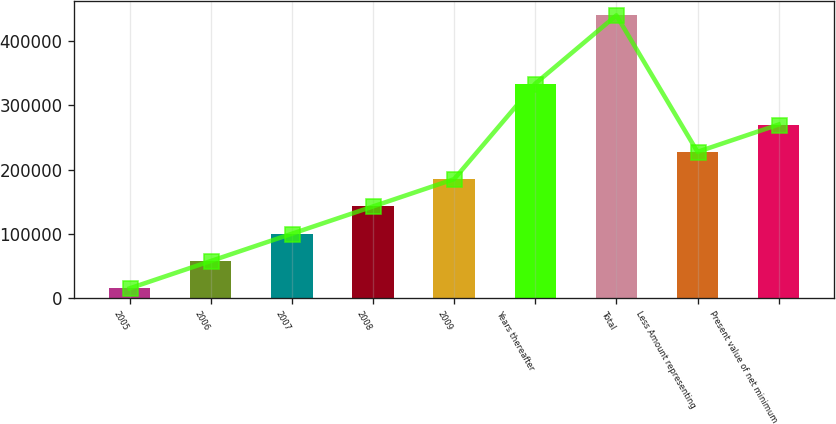<chart> <loc_0><loc_0><loc_500><loc_500><bar_chart><fcel>2005<fcel>2006<fcel>2007<fcel>2008<fcel>2009<fcel>Years thereafter<fcel>Total<fcel>Less Amount representing<fcel>Present value of net minimum<nl><fcel>14554<fcel>57167.5<fcel>99781<fcel>142394<fcel>185008<fcel>334062<fcel>440689<fcel>227622<fcel>270235<nl></chart> 